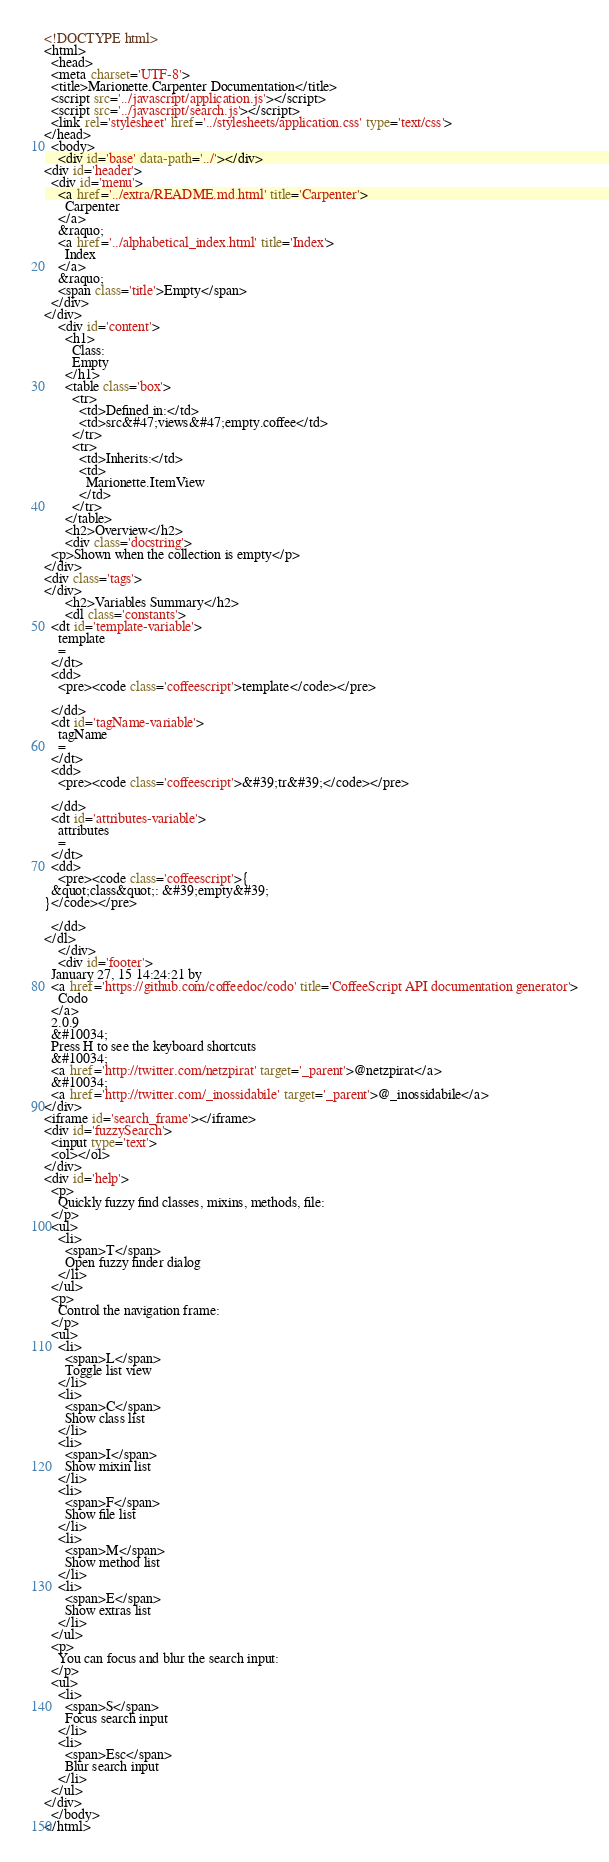<code> <loc_0><loc_0><loc_500><loc_500><_HTML_><!DOCTYPE html>
<html>
  <head>
  <meta charset='UTF-8'>
  <title>Marionette.Carpenter Documentation</title>
  <script src='../javascript/application.js'></script>
  <script src='../javascript/search.js'></script>
  <link rel='stylesheet' href='../stylesheets/application.css' type='text/css'>
</head>
  <body>
    <div id='base' data-path='../'></div>
<div id='header'>
  <div id='menu'>
    <a href='../extra/README.md.html' title='Carpenter'>
      Carpenter
    </a>
    &raquo;
    <a href='../alphabetical_index.html' title='Index'>
      Index
    </a>
    &raquo;
    <span class='title'>Empty</span>
  </div>
</div>
    <div id='content'>
      <h1>
        Class:
        Empty
      </h1>
      <table class='box'>
        <tr>
          <td>Defined in:</td>
          <td>src&#47;views&#47;empty.coffee</td>
        </tr>
        <tr>
          <td>Inherits:</td>
          <td>
            Marionette.ItemView
          </td>
        </tr>
      </table>
      <h2>Overview</h2>
      <div class='docstring'>
  <p>Shown when the collection is empty</p>
</div>
<div class='tags'>
</div>
      <h2>Variables Summary</h2>
      <dl class='constants'>
  <dt id='template-variable'>
    template
    =
  </dt>
  <dd>
    <pre><code class='coffeescript'>template</code></pre>
    
  </dd>
  <dt id='tagName-variable'>
    tagName
    =
  </dt>
  <dd>
    <pre><code class='coffeescript'>&#39;tr&#39;</code></pre>
    
  </dd>
  <dt id='attributes-variable'>
    attributes
    =
  </dt>
  <dd>
    <pre><code class='coffeescript'>{
  &quot;class&quot;: &#39;empty&#39;
}</code></pre>
    
  </dd>
</dl>
    </div>
    <div id='footer'>
  January 27, 15 14:24:21 by
  <a href='https://github.com/coffeedoc/codo' title='CoffeeScript API documentation generator'>
    Codo
  </a>
  2.0.9
  &#10034;
  Press H to see the keyboard shortcuts
  &#10034;
  <a href='http://twitter.com/netzpirat' target='_parent'>@netzpirat</a>
  &#10034;
  <a href='http://twitter.com/_inossidabile' target='_parent'>@_inossidabile</a>
</div>
<iframe id='search_frame'></iframe>
<div id='fuzzySearch'>
  <input type='text'>
  <ol></ol>
</div>
<div id='help'>
  <p>
    Quickly fuzzy find classes, mixins, methods, file:
  </p>
  <ul>
    <li>
      <span>T</span>
      Open fuzzy finder dialog
    </li>
  </ul>
  <p>
    Control the navigation frame:
  </p>
  <ul>
    <li>
      <span>L</span>
      Toggle list view
    </li>
    <li>
      <span>C</span>
      Show class list
    </li>
    <li>
      <span>I</span>
      Show mixin list
    </li>
    <li>
      <span>F</span>
      Show file list
    </li>
    <li>
      <span>M</span>
      Show method list
    </li>
    <li>
      <span>E</span>
      Show extras list
    </li>
  </ul>
  <p>
    You can focus and blur the search input:
  </p>
  <ul>
    <li>
      <span>S</span>
      Focus search input
    </li>
    <li>
      <span>Esc</span>
      Blur search input
    </li>
  </ul>
</div>
  </body>
</html></code> 